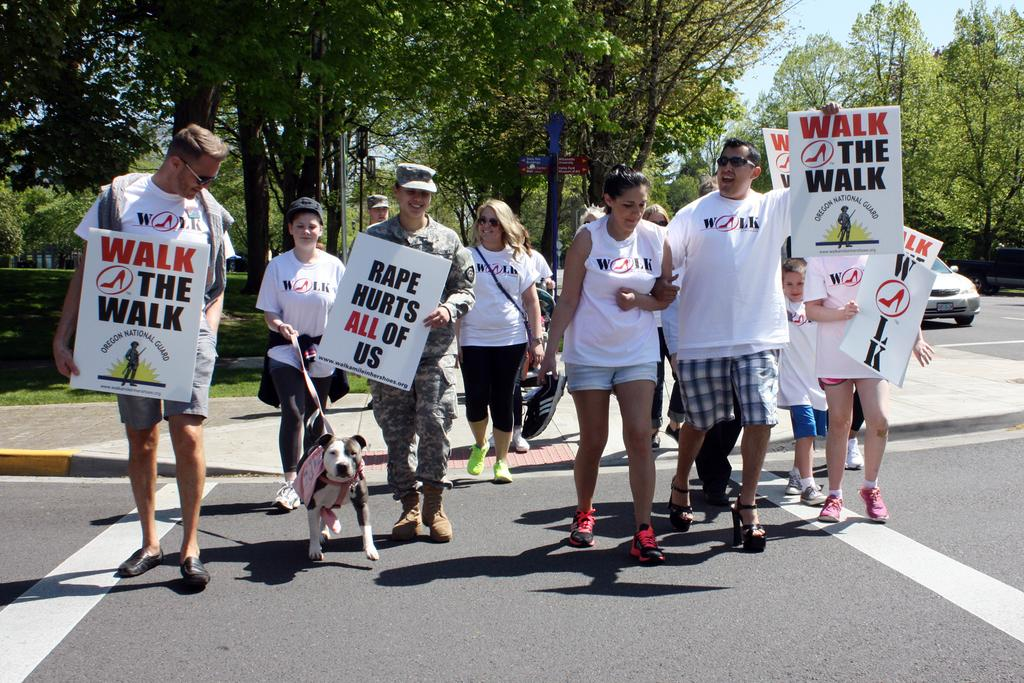What are the people in the image doing? The people in the image are walking on the roads. What are the people holding while walking? The people are holding placards. What can be seen in the distance behind the people? There are trees visible in the background. What type of committee is meeting in the image? There is no committee meeting in the image; it shows people walking on the roads while holding placards. Can you see any fangs on the people in the image? There are no fangs visible on the people in the image. 